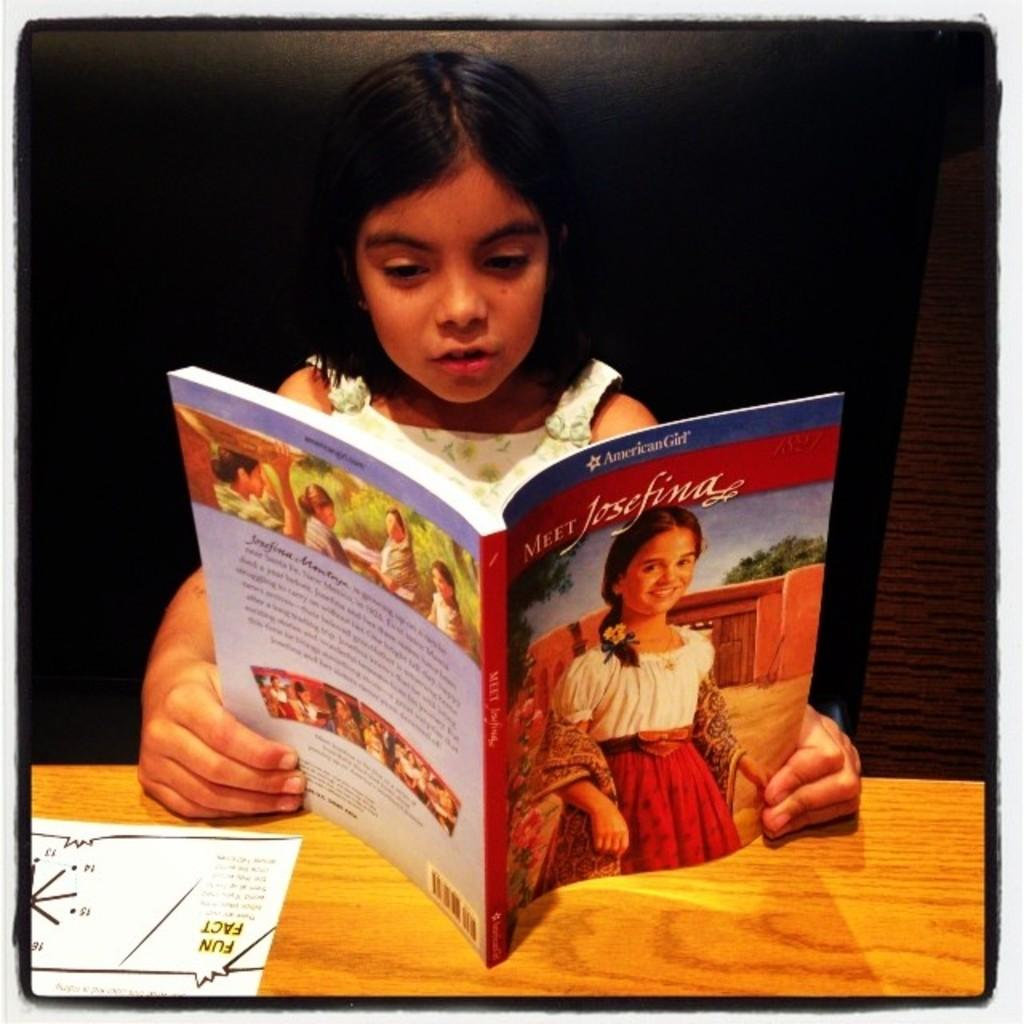Provide a one-sentence caption for the provided image. The little girl is reading a storybook name "Meet Josefina". 